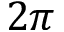Convert formula to latex. <formula><loc_0><loc_0><loc_500><loc_500>2 \pi</formula> 